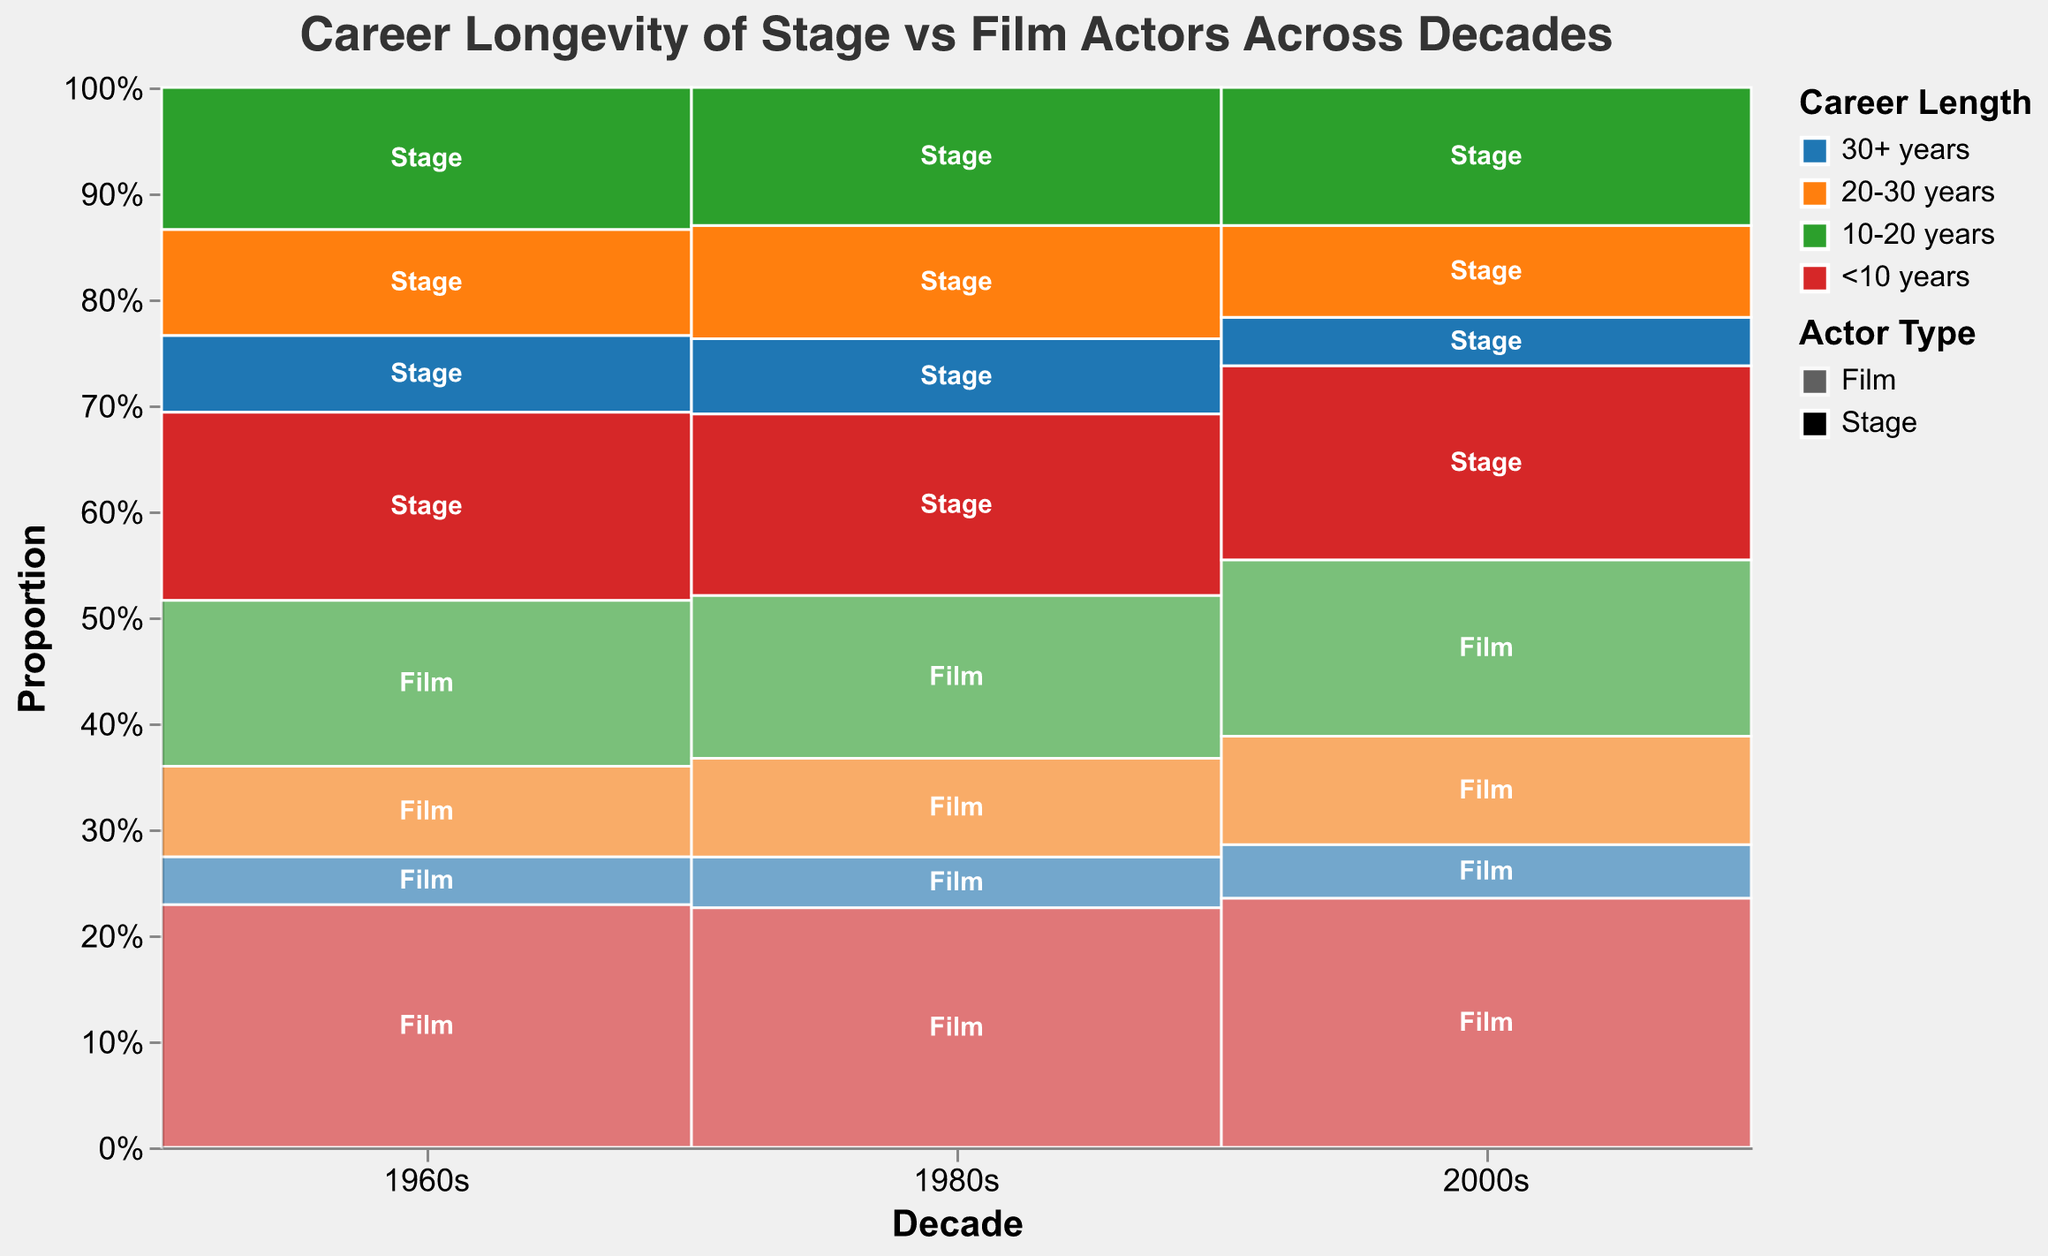What is the title of the mosaic plot? The title can be seen at the top of the figure, displaying the overall topic of the visualization.
Answer: Career Longevity of Stage vs Film Actors Across Decades What are the different career length categories represented in the plot? These are labeled distinctly in the plot's legend.
Answer: 30+ years, 20-30 years, 10-20 years, <10 years Which decade has the highest count of stage actors with career lengths less than 10 years? Look at the various segments for stage actors across different decades and identify the one with the largest segment for "<10 years".
Answer: 2000s How many total counts of stage actors are there in the 1960s? Add the counts of all career length categories for stage actors in the 1960s.
Answer: 300 Comparing the 1960s and 1980s, which decade had more film actors with career lengths of 30+ years? Compare the segments representing "30+ years" for film actors between the 1960s and 1980s.
Answer: 1980s In the 2000s, what proportion of stage actors had careers of 30+ years? Calculate the ratio of stage actors with careers of 30+ years to the total stage actors in the 2000s.
Answer: 38/370 Which actor type had a higher count in the 1980s for careers of 10-20 years? Compare the counts of stage actors and film actors with careers of 10-20 years in the 1980s.
Answer: Film actors How does the proportion of film actors with career lengths of <10 years change from the 1960s to the 2000s? Compare the relative heights of the "<10 years" segments for film actors between the two decades.
Answer: Increases What is the common trend in career length for both stage and film actors across the decades? Observe the vertical sizes of each career length segment for both stage and film actors across all decades.
Answer: Decreasing career length over time Which decade has the lowest overall proportion of stage actors with careers of 30+ years? Identify the shortest segment for stage actors with 30+ year careers across all decades.
Answer: 2000s 